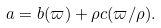<formula> <loc_0><loc_0><loc_500><loc_500>a = b ( \varpi ) + \rho c ( \varpi / \rho ) .</formula> 